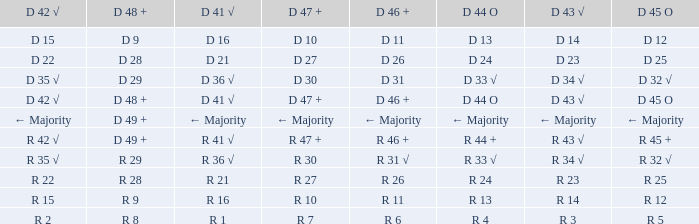What is the value of D 45 O when the value of D 44 O is ← majority? ← Majority. 